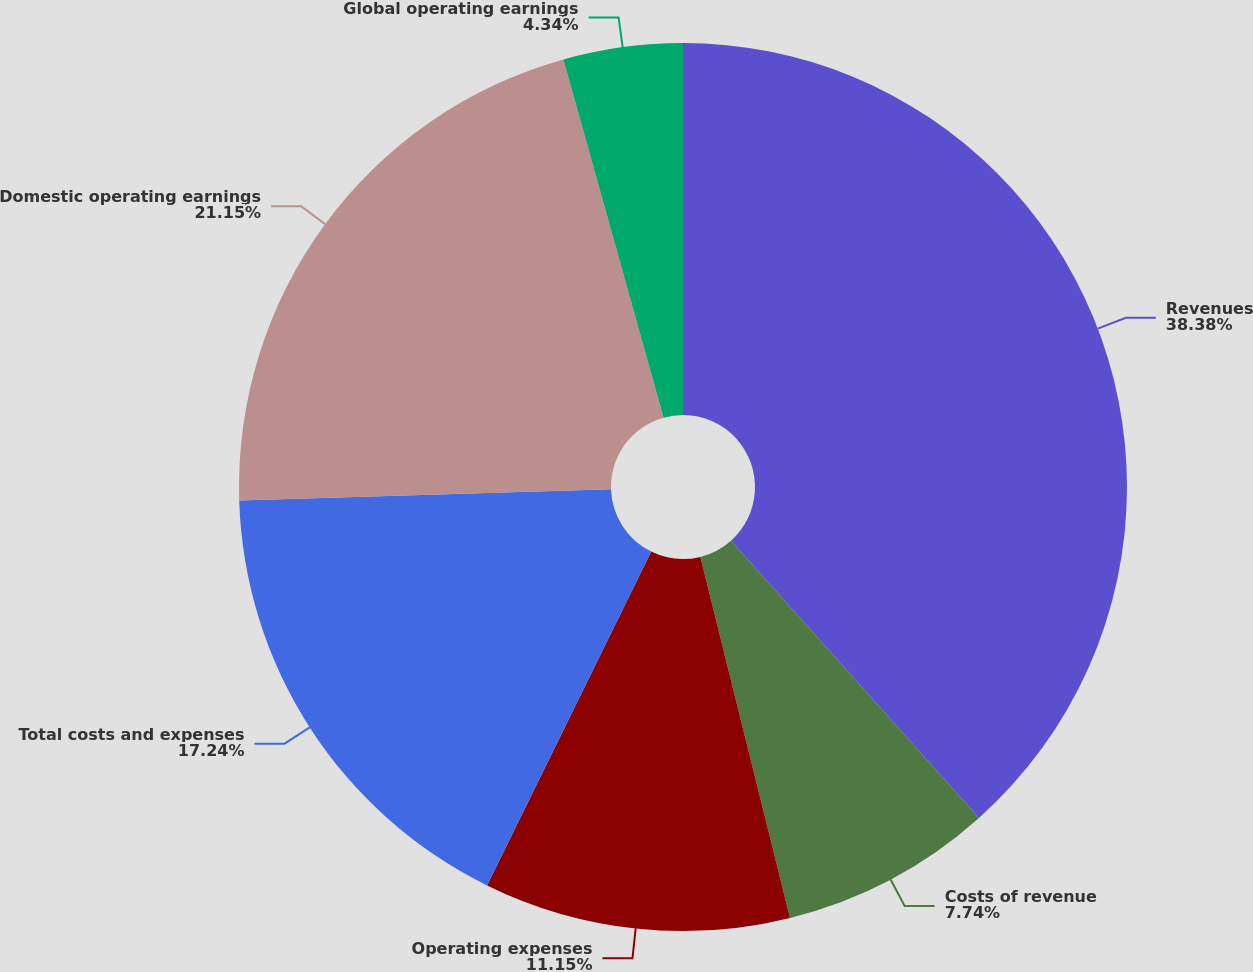Convert chart. <chart><loc_0><loc_0><loc_500><loc_500><pie_chart><fcel>Revenues<fcel>Costs of revenue<fcel>Operating expenses<fcel>Total costs and expenses<fcel>Domestic operating earnings<fcel>Global operating earnings<nl><fcel>38.39%<fcel>7.74%<fcel>11.15%<fcel>17.24%<fcel>21.15%<fcel>4.34%<nl></chart> 